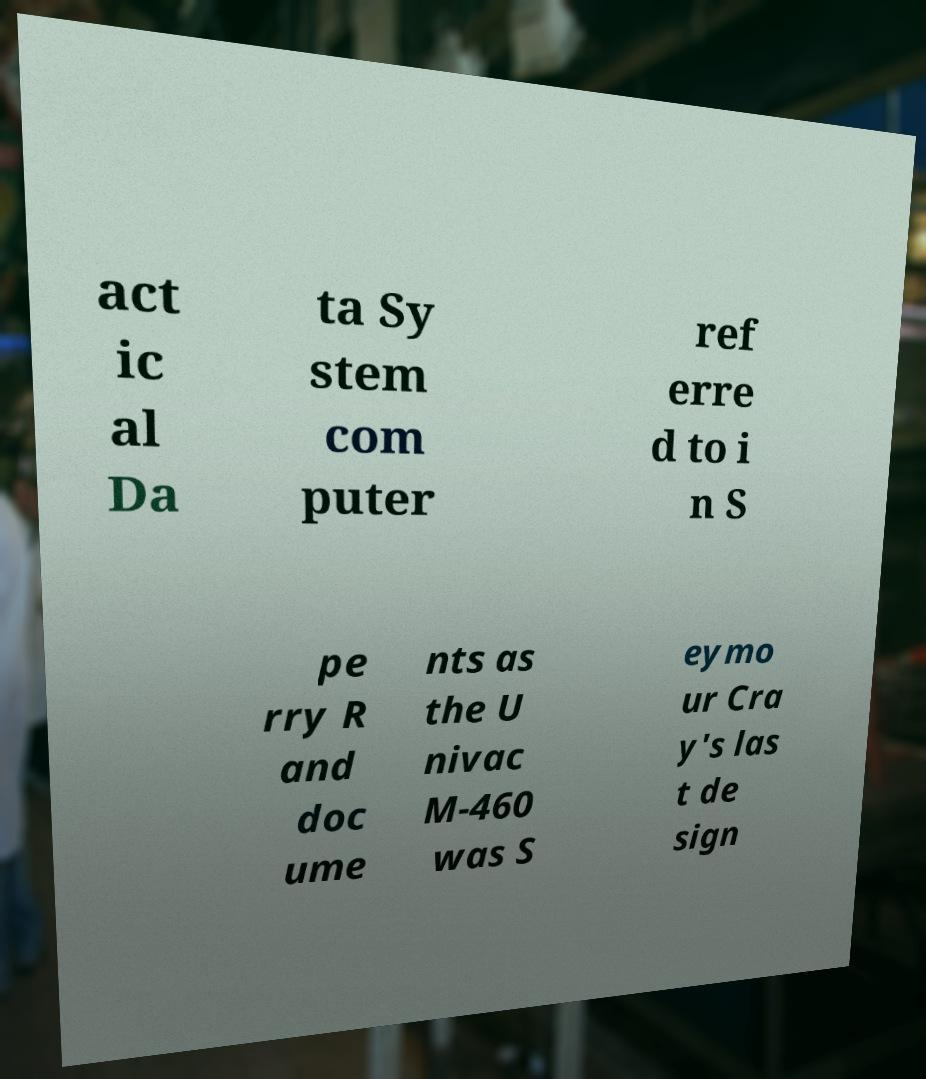Could you assist in decoding the text presented in this image and type it out clearly? act ic al Da ta Sy stem com puter ref erre d to i n S pe rry R and doc ume nts as the U nivac M-460 was S eymo ur Cra y's las t de sign 